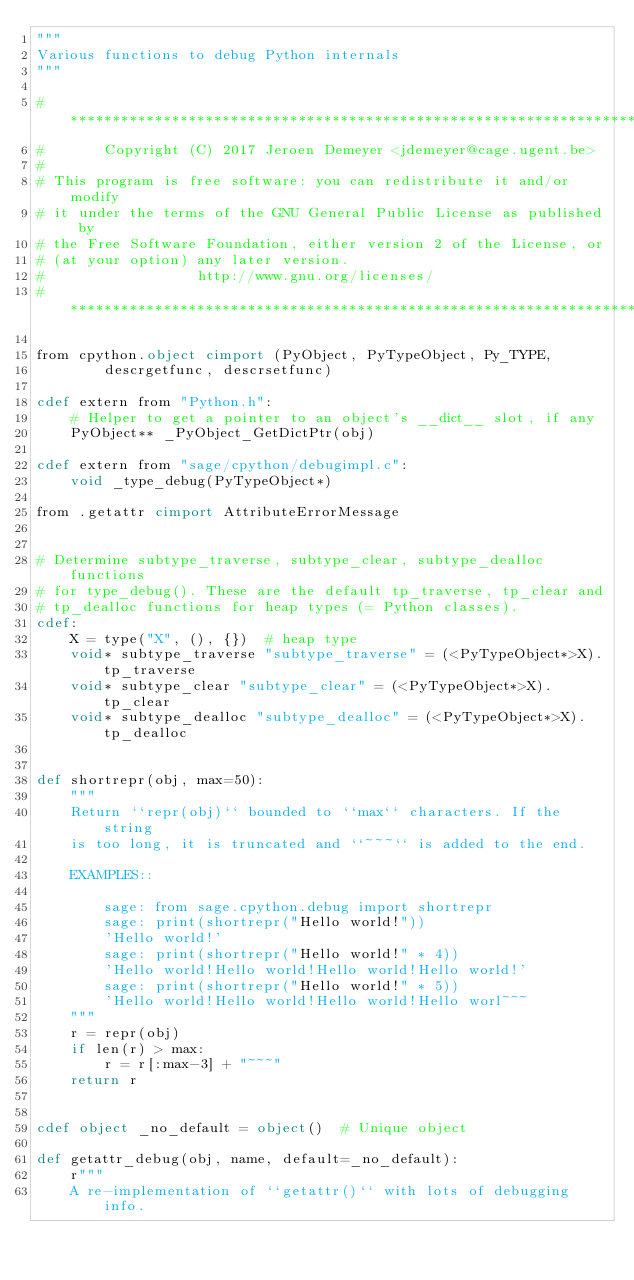Convert code to text. <code><loc_0><loc_0><loc_500><loc_500><_Cython_>"""
Various functions to debug Python internals
"""

#*****************************************************************************
#       Copyright (C) 2017 Jeroen Demeyer <jdemeyer@cage.ugent.be>
#
# This program is free software: you can redistribute it and/or modify
# it under the terms of the GNU General Public License as published by
# the Free Software Foundation, either version 2 of the License, or
# (at your option) any later version.
#                  http://www.gnu.org/licenses/
#*****************************************************************************

from cpython.object cimport (PyObject, PyTypeObject, Py_TYPE,
        descrgetfunc, descrsetfunc)

cdef extern from "Python.h":
    # Helper to get a pointer to an object's __dict__ slot, if any
    PyObject** _PyObject_GetDictPtr(obj)

cdef extern from "sage/cpython/debugimpl.c":
    void _type_debug(PyTypeObject*)

from .getattr cimport AttributeErrorMessage


# Determine subtype_traverse, subtype_clear, subtype_dealloc functions
# for type_debug(). These are the default tp_traverse, tp_clear and
# tp_dealloc functions for heap types (= Python classes).
cdef:
    X = type("X", (), {})  # heap type
    void* subtype_traverse "subtype_traverse" = (<PyTypeObject*>X).tp_traverse
    void* subtype_clear "subtype_clear" = (<PyTypeObject*>X).tp_clear
    void* subtype_dealloc "subtype_dealloc" = (<PyTypeObject*>X).tp_dealloc


def shortrepr(obj, max=50):
    """
    Return ``repr(obj)`` bounded to ``max`` characters. If the string
    is too long, it is truncated and ``~~~`` is added to the end.

    EXAMPLES::

        sage: from sage.cpython.debug import shortrepr
        sage: print(shortrepr("Hello world!"))
        'Hello world!'
        sage: print(shortrepr("Hello world!" * 4))
        'Hello world!Hello world!Hello world!Hello world!'
        sage: print(shortrepr("Hello world!" * 5))
        'Hello world!Hello world!Hello world!Hello worl~~~
    """
    r = repr(obj)
    if len(r) > max:
        r = r[:max-3] + "~~~"
    return r


cdef object _no_default = object()  # Unique object

def getattr_debug(obj, name, default=_no_default):
    r"""
    A re-implementation of ``getattr()`` with lots of debugging info.
</code> 